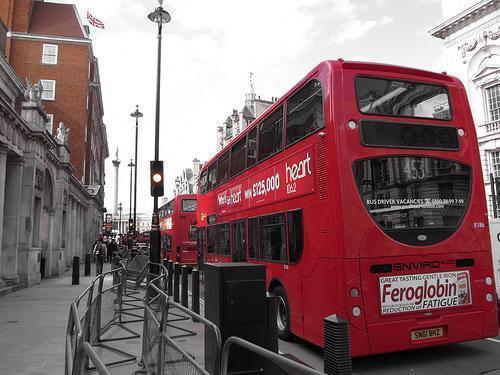How many buses are shown?
Give a very brief answer. 2. 